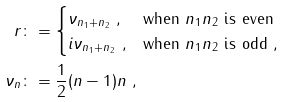Convert formula to latex. <formula><loc_0><loc_0><loc_500><loc_500>r & \colon = \begin{cases} \nu _ { n _ { 1 } + n _ { 2 } } \ , & \text {when } n _ { 1 } n _ { 2 } \text { is even} \\ i \nu _ { n _ { 1 } + n _ { 2 } } \ , & \text {when } n _ { 1 } n _ { 2 } \text { is odd} \ , \end{cases} \\ \nu _ { n } & \colon = \frac { 1 } { 2 } ( n - 1 ) n \ ,</formula> 